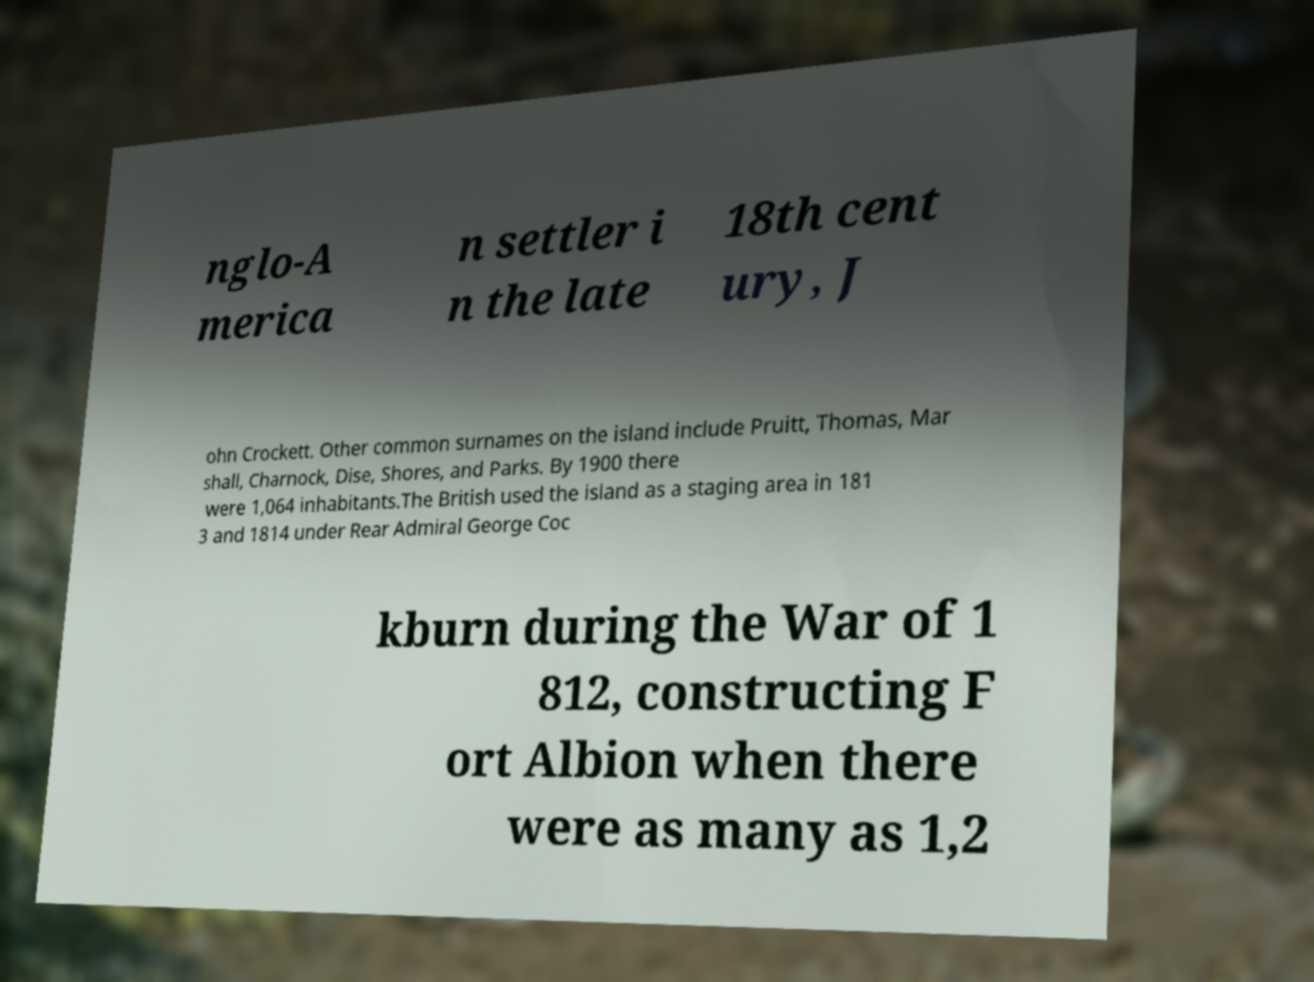Could you extract and type out the text from this image? nglo-A merica n settler i n the late 18th cent ury, J ohn Crockett. Other common surnames on the island include Pruitt, Thomas, Mar shall, Charnock, Dise, Shores, and Parks. By 1900 there were 1,064 inhabitants.The British used the island as a staging area in 181 3 and 1814 under Rear Admiral George Coc kburn during the War of 1 812, constructing F ort Albion when there were as many as 1,2 